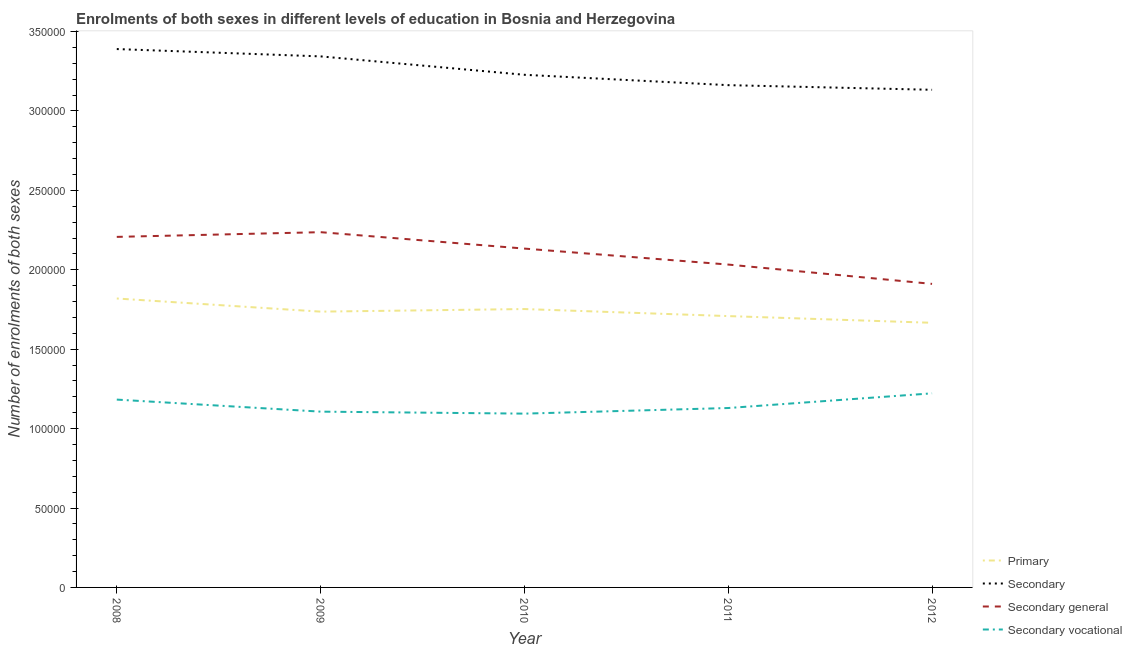How many different coloured lines are there?
Ensure brevity in your answer.  4. Does the line corresponding to number of enrolments in primary education intersect with the line corresponding to number of enrolments in secondary education?
Provide a succinct answer. No. Is the number of lines equal to the number of legend labels?
Offer a very short reply. Yes. What is the number of enrolments in primary education in 2009?
Provide a succinct answer. 1.74e+05. Across all years, what is the maximum number of enrolments in secondary general education?
Provide a short and direct response. 2.24e+05. Across all years, what is the minimum number of enrolments in secondary education?
Provide a short and direct response. 3.13e+05. In which year was the number of enrolments in secondary vocational education minimum?
Offer a very short reply. 2010. What is the total number of enrolments in secondary vocational education in the graph?
Provide a succinct answer. 5.74e+05. What is the difference between the number of enrolments in secondary vocational education in 2008 and that in 2010?
Your answer should be compact. 8838. What is the difference between the number of enrolments in secondary vocational education in 2012 and the number of enrolments in secondary education in 2010?
Give a very brief answer. -2.01e+05. What is the average number of enrolments in secondary general education per year?
Make the answer very short. 2.10e+05. In the year 2012, what is the difference between the number of enrolments in secondary vocational education and number of enrolments in primary education?
Provide a short and direct response. -4.44e+04. What is the ratio of the number of enrolments in secondary general education in 2008 to that in 2010?
Ensure brevity in your answer.  1.03. Is the difference between the number of enrolments in secondary vocational education in 2008 and 2009 greater than the difference between the number of enrolments in secondary education in 2008 and 2009?
Offer a terse response. Yes. What is the difference between the highest and the second highest number of enrolments in secondary education?
Your response must be concise. 4616. What is the difference between the highest and the lowest number of enrolments in secondary vocational education?
Give a very brief answer. 1.28e+04. In how many years, is the number of enrolments in secondary education greater than the average number of enrolments in secondary education taken over all years?
Your response must be concise. 2. Is the sum of the number of enrolments in secondary education in 2008 and 2012 greater than the maximum number of enrolments in secondary vocational education across all years?
Ensure brevity in your answer.  Yes. Is it the case that in every year, the sum of the number of enrolments in primary education and number of enrolments in secondary education is greater than the number of enrolments in secondary general education?
Your answer should be compact. Yes. Does the number of enrolments in primary education monotonically increase over the years?
Keep it short and to the point. No. Is the number of enrolments in secondary vocational education strictly less than the number of enrolments in secondary general education over the years?
Keep it short and to the point. Yes. What is the difference between two consecutive major ticks on the Y-axis?
Keep it short and to the point. 5.00e+04. Are the values on the major ticks of Y-axis written in scientific E-notation?
Make the answer very short. No. Does the graph contain any zero values?
Give a very brief answer. No. How many legend labels are there?
Give a very brief answer. 4. What is the title of the graph?
Keep it short and to the point. Enrolments of both sexes in different levels of education in Bosnia and Herzegovina. Does "France" appear as one of the legend labels in the graph?
Offer a very short reply. No. What is the label or title of the X-axis?
Give a very brief answer. Year. What is the label or title of the Y-axis?
Keep it short and to the point. Number of enrolments of both sexes. What is the Number of enrolments of both sexes of Primary in 2008?
Provide a succinct answer. 1.82e+05. What is the Number of enrolments of both sexes of Secondary in 2008?
Provide a short and direct response. 3.39e+05. What is the Number of enrolments of both sexes in Secondary general in 2008?
Provide a succinct answer. 2.21e+05. What is the Number of enrolments of both sexes of Secondary vocational in 2008?
Keep it short and to the point. 1.18e+05. What is the Number of enrolments of both sexes in Primary in 2009?
Your answer should be very brief. 1.74e+05. What is the Number of enrolments of both sexes of Secondary in 2009?
Your answer should be very brief. 3.34e+05. What is the Number of enrolments of both sexes of Secondary general in 2009?
Offer a terse response. 2.24e+05. What is the Number of enrolments of both sexes of Secondary vocational in 2009?
Keep it short and to the point. 1.11e+05. What is the Number of enrolments of both sexes in Primary in 2010?
Provide a succinct answer. 1.75e+05. What is the Number of enrolments of both sexes of Secondary in 2010?
Offer a very short reply. 3.23e+05. What is the Number of enrolments of both sexes in Secondary general in 2010?
Your response must be concise. 2.13e+05. What is the Number of enrolments of both sexes in Secondary vocational in 2010?
Provide a short and direct response. 1.09e+05. What is the Number of enrolments of both sexes of Primary in 2011?
Give a very brief answer. 1.71e+05. What is the Number of enrolments of both sexes in Secondary in 2011?
Keep it short and to the point. 3.16e+05. What is the Number of enrolments of both sexes in Secondary general in 2011?
Make the answer very short. 2.03e+05. What is the Number of enrolments of both sexes of Secondary vocational in 2011?
Your answer should be compact. 1.13e+05. What is the Number of enrolments of both sexes of Primary in 2012?
Your answer should be compact. 1.67e+05. What is the Number of enrolments of both sexes in Secondary in 2012?
Keep it short and to the point. 3.13e+05. What is the Number of enrolments of both sexes of Secondary general in 2012?
Your answer should be compact. 1.91e+05. What is the Number of enrolments of both sexes of Secondary vocational in 2012?
Provide a short and direct response. 1.22e+05. Across all years, what is the maximum Number of enrolments of both sexes in Primary?
Offer a terse response. 1.82e+05. Across all years, what is the maximum Number of enrolments of both sexes in Secondary?
Your answer should be very brief. 3.39e+05. Across all years, what is the maximum Number of enrolments of both sexes of Secondary general?
Your response must be concise. 2.24e+05. Across all years, what is the maximum Number of enrolments of both sexes in Secondary vocational?
Offer a terse response. 1.22e+05. Across all years, what is the minimum Number of enrolments of both sexes in Primary?
Provide a short and direct response. 1.67e+05. Across all years, what is the minimum Number of enrolments of both sexes of Secondary?
Provide a succinct answer. 3.13e+05. Across all years, what is the minimum Number of enrolments of both sexes of Secondary general?
Make the answer very short. 1.91e+05. Across all years, what is the minimum Number of enrolments of both sexes of Secondary vocational?
Provide a succinct answer. 1.09e+05. What is the total Number of enrolments of both sexes of Primary in the graph?
Your answer should be very brief. 8.68e+05. What is the total Number of enrolments of both sexes of Secondary in the graph?
Make the answer very short. 1.63e+06. What is the total Number of enrolments of both sexes in Secondary general in the graph?
Your answer should be compact. 1.05e+06. What is the total Number of enrolments of both sexes of Secondary vocational in the graph?
Ensure brevity in your answer.  5.74e+05. What is the difference between the Number of enrolments of both sexes in Primary in 2008 and that in 2009?
Make the answer very short. 8270. What is the difference between the Number of enrolments of both sexes of Secondary in 2008 and that in 2009?
Keep it short and to the point. 4616. What is the difference between the Number of enrolments of both sexes of Secondary general in 2008 and that in 2009?
Keep it short and to the point. -2965. What is the difference between the Number of enrolments of both sexes in Secondary vocational in 2008 and that in 2009?
Your response must be concise. 7581. What is the difference between the Number of enrolments of both sexes of Primary in 2008 and that in 2010?
Ensure brevity in your answer.  6646. What is the difference between the Number of enrolments of both sexes in Secondary in 2008 and that in 2010?
Provide a short and direct response. 1.62e+04. What is the difference between the Number of enrolments of both sexes of Secondary general in 2008 and that in 2010?
Ensure brevity in your answer.  7367. What is the difference between the Number of enrolments of both sexes of Secondary vocational in 2008 and that in 2010?
Provide a succinct answer. 8838. What is the difference between the Number of enrolments of both sexes in Primary in 2008 and that in 2011?
Give a very brief answer. 1.11e+04. What is the difference between the Number of enrolments of both sexes in Secondary in 2008 and that in 2011?
Offer a very short reply. 2.27e+04. What is the difference between the Number of enrolments of both sexes of Secondary general in 2008 and that in 2011?
Provide a short and direct response. 1.74e+04. What is the difference between the Number of enrolments of both sexes of Secondary vocational in 2008 and that in 2011?
Provide a short and direct response. 5300. What is the difference between the Number of enrolments of both sexes in Primary in 2008 and that in 2012?
Your answer should be very brief. 1.53e+04. What is the difference between the Number of enrolments of both sexes in Secondary in 2008 and that in 2012?
Offer a very short reply. 2.56e+04. What is the difference between the Number of enrolments of both sexes of Secondary general in 2008 and that in 2012?
Offer a very short reply. 2.96e+04. What is the difference between the Number of enrolments of both sexes in Secondary vocational in 2008 and that in 2012?
Provide a short and direct response. -3941. What is the difference between the Number of enrolments of both sexes in Primary in 2009 and that in 2010?
Make the answer very short. -1624. What is the difference between the Number of enrolments of both sexes in Secondary in 2009 and that in 2010?
Provide a succinct answer. 1.16e+04. What is the difference between the Number of enrolments of both sexes in Secondary general in 2009 and that in 2010?
Your answer should be very brief. 1.03e+04. What is the difference between the Number of enrolments of both sexes in Secondary vocational in 2009 and that in 2010?
Your response must be concise. 1257. What is the difference between the Number of enrolments of both sexes of Primary in 2009 and that in 2011?
Make the answer very short. 2805. What is the difference between the Number of enrolments of both sexes of Secondary in 2009 and that in 2011?
Ensure brevity in your answer.  1.81e+04. What is the difference between the Number of enrolments of both sexes in Secondary general in 2009 and that in 2011?
Offer a very short reply. 2.04e+04. What is the difference between the Number of enrolments of both sexes in Secondary vocational in 2009 and that in 2011?
Offer a very short reply. -2281. What is the difference between the Number of enrolments of both sexes of Primary in 2009 and that in 2012?
Your response must be concise. 7027. What is the difference between the Number of enrolments of both sexes of Secondary in 2009 and that in 2012?
Offer a terse response. 2.10e+04. What is the difference between the Number of enrolments of both sexes of Secondary general in 2009 and that in 2012?
Keep it short and to the point. 3.26e+04. What is the difference between the Number of enrolments of both sexes in Secondary vocational in 2009 and that in 2012?
Offer a terse response. -1.15e+04. What is the difference between the Number of enrolments of both sexes of Primary in 2010 and that in 2011?
Ensure brevity in your answer.  4429. What is the difference between the Number of enrolments of both sexes of Secondary in 2010 and that in 2011?
Give a very brief answer. 6525. What is the difference between the Number of enrolments of both sexes in Secondary general in 2010 and that in 2011?
Provide a short and direct response. 1.01e+04. What is the difference between the Number of enrolments of both sexes of Secondary vocational in 2010 and that in 2011?
Keep it short and to the point. -3538. What is the difference between the Number of enrolments of both sexes in Primary in 2010 and that in 2012?
Make the answer very short. 8651. What is the difference between the Number of enrolments of both sexes in Secondary in 2010 and that in 2012?
Your answer should be very brief. 9445. What is the difference between the Number of enrolments of both sexes in Secondary general in 2010 and that in 2012?
Offer a very short reply. 2.22e+04. What is the difference between the Number of enrolments of both sexes of Secondary vocational in 2010 and that in 2012?
Your response must be concise. -1.28e+04. What is the difference between the Number of enrolments of both sexes in Primary in 2011 and that in 2012?
Offer a terse response. 4222. What is the difference between the Number of enrolments of both sexes of Secondary in 2011 and that in 2012?
Keep it short and to the point. 2920. What is the difference between the Number of enrolments of both sexes of Secondary general in 2011 and that in 2012?
Keep it short and to the point. 1.22e+04. What is the difference between the Number of enrolments of both sexes in Secondary vocational in 2011 and that in 2012?
Make the answer very short. -9241. What is the difference between the Number of enrolments of both sexes in Primary in 2008 and the Number of enrolments of both sexes in Secondary in 2009?
Your answer should be compact. -1.52e+05. What is the difference between the Number of enrolments of both sexes of Primary in 2008 and the Number of enrolments of both sexes of Secondary general in 2009?
Your response must be concise. -4.18e+04. What is the difference between the Number of enrolments of both sexes in Primary in 2008 and the Number of enrolments of both sexes in Secondary vocational in 2009?
Offer a terse response. 7.12e+04. What is the difference between the Number of enrolments of both sexes in Secondary in 2008 and the Number of enrolments of both sexes in Secondary general in 2009?
Make the answer very short. 1.15e+05. What is the difference between the Number of enrolments of both sexes in Secondary in 2008 and the Number of enrolments of both sexes in Secondary vocational in 2009?
Make the answer very short. 2.28e+05. What is the difference between the Number of enrolments of both sexes of Secondary general in 2008 and the Number of enrolments of both sexes of Secondary vocational in 2009?
Ensure brevity in your answer.  1.10e+05. What is the difference between the Number of enrolments of both sexes in Primary in 2008 and the Number of enrolments of both sexes in Secondary in 2010?
Your response must be concise. -1.41e+05. What is the difference between the Number of enrolments of both sexes of Primary in 2008 and the Number of enrolments of both sexes of Secondary general in 2010?
Your answer should be compact. -3.14e+04. What is the difference between the Number of enrolments of both sexes of Primary in 2008 and the Number of enrolments of both sexes of Secondary vocational in 2010?
Give a very brief answer. 7.25e+04. What is the difference between the Number of enrolments of both sexes in Secondary in 2008 and the Number of enrolments of both sexes in Secondary general in 2010?
Offer a very short reply. 1.26e+05. What is the difference between the Number of enrolments of both sexes in Secondary in 2008 and the Number of enrolments of both sexes in Secondary vocational in 2010?
Offer a very short reply. 2.30e+05. What is the difference between the Number of enrolments of both sexes of Secondary general in 2008 and the Number of enrolments of both sexes of Secondary vocational in 2010?
Ensure brevity in your answer.  1.11e+05. What is the difference between the Number of enrolments of both sexes of Primary in 2008 and the Number of enrolments of both sexes of Secondary in 2011?
Your answer should be very brief. -1.34e+05. What is the difference between the Number of enrolments of both sexes of Primary in 2008 and the Number of enrolments of both sexes of Secondary general in 2011?
Offer a very short reply. -2.14e+04. What is the difference between the Number of enrolments of both sexes of Primary in 2008 and the Number of enrolments of both sexes of Secondary vocational in 2011?
Give a very brief answer. 6.90e+04. What is the difference between the Number of enrolments of both sexes in Secondary in 2008 and the Number of enrolments of both sexes in Secondary general in 2011?
Your response must be concise. 1.36e+05. What is the difference between the Number of enrolments of both sexes of Secondary in 2008 and the Number of enrolments of both sexes of Secondary vocational in 2011?
Provide a short and direct response. 2.26e+05. What is the difference between the Number of enrolments of both sexes in Secondary general in 2008 and the Number of enrolments of both sexes in Secondary vocational in 2011?
Make the answer very short. 1.08e+05. What is the difference between the Number of enrolments of both sexes of Primary in 2008 and the Number of enrolments of both sexes of Secondary in 2012?
Your answer should be compact. -1.31e+05. What is the difference between the Number of enrolments of both sexes of Primary in 2008 and the Number of enrolments of both sexes of Secondary general in 2012?
Provide a succinct answer. -9201. What is the difference between the Number of enrolments of both sexes of Primary in 2008 and the Number of enrolments of both sexes of Secondary vocational in 2012?
Provide a succinct answer. 5.97e+04. What is the difference between the Number of enrolments of both sexes of Secondary in 2008 and the Number of enrolments of both sexes of Secondary general in 2012?
Offer a terse response. 1.48e+05. What is the difference between the Number of enrolments of both sexes in Secondary in 2008 and the Number of enrolments of both sexes in Secondary vocational in 2012?
Offer a terse response. 2.17e+05. What is the difference between the Number of enrolments of both sexes of Secondary general in 2008 and the Number of enrolments of both sexes of Secondary vocational in 2012?
Make the answer very short. 9.85e+04. What is the difference between the Number of enrolments of both sexes of Primary in 2009 and the Number of enrolments of both sexes of Secondary in 2010?
Your answer should be very brief. -1.49e+05. What is the difference between the Number of enrolments of both sexes in Primary in 2009 and the Number of enrolments of both sexes in Secondary general in 2010?
Your answer should be compact. -3.97e+04. What is the difference between the Number of enrolments of both sexes in Primary in 2009 and the Number of enrolments of both sexes in Secondary vocational in 2010?
Your response must be concise. 6.42e+04. What is the difference between the Number of enrolments of both sexes in Secondary in 2009 and the Number of enrolments of both sexes in Secondary general in 2010?
Your response must be concise. 1.21e+05. What is the difference between the Number of enrolments of both sexes in Secondary in 2009 and the Number of enrolments of both sexes in Secondary vocational in 2010?
Provide a short and direct response. 2.25e+05. What is the difference between the Number of enrolments of both sexes in Secondary general in 2009 and the Number of enrolments of both sexes in Secondary vocational in 2010?
Provide a succinct answer. 1.14e+05. What is the difference between the Number of enrolments of both sexes in Primary in 2009 and the Number of enrolments of both sexes in Secondary in 2011?
Make the answer very short. -1.43e+05. What is the difference between the Number of enrolments of both sexes of Primary in 2009 and the Number of enrolments of both sexes of Secondary general in 2011?
Your response must be concise. -2.96e+04. What is the difference between the Number of enrolments of both sexes in Primary in 2009 and the Number of enrolments of both sexes in Secondary vocational in 2011?
Offer a terse response. 6.07e+04. What is the difference between the Number of enrolments of both sexes of Secondary in 2009 and the Number of enrolments of both sexes of Secondary general in 2011?
Keep it short and to the point. 1.31e+05. What is the difference between the Number of enrolments of both sexes in Secondary in 2009 and the Number of enrolments of both sexes in Secondary vocational in 2011?
Your response must be concise. 2.21e+05. What is the difference between the Number of enrolments of both sexes of Secondary general in 2009 and the Number of enrolments of both sexes of Secondary vocational in 2011?
Keep it short and to the point. 1.11e+05. What is the difference between the Number of enrolments of both sexes in Primary in 2009 and the Number of enrolments of both sexes in Secondary in 2012?
Offer a terse response. -1.40e+05. What is the difference between the Number of enrolments of both sexes of Primary in 2009 and the Number of enrolments of both sexes of Secondary general in 2012?
Make the answer very short. -1.75e+04. What is the difference between the Number of enrolments of both sexes in Primary in 2009 and the Number of enrolments of both sexes in Secondary vocational in 2012?
Offer a terse response. 5.14e+04. What is the difference between the Number of enrolments of both sexes of Secondary in 2009 and the Number of enrolments of both sexes of Secondary general in 2012?
Make the answer very short. 1.43e+05. What is the difference between the Number of enrolments of both sexes in Secondary in 2009 and the Number of enrolments of both sexes in Secondary vocational in 2012?
Your answer should be compact. 2.12e+05. What is the difference between the Number of enrolments of both sexes of Secondary general in 2009 and the Number of enrolments of both sexes of Secondary vocational in 2012?
Offer a very short reply. 1.01e+05. What is the difference between the Number of enrolments of both sexes of Primary in 2010 and the Number of enrolments of both sexes of Secondary in 2011?
Ensure brevity in your answer.  -1.41e+05. What is the difference between the Number of enrolments of both sexes in Primary in 2010 and the Number of enrolments of both sexes in Secondary general in 2011?
Ensure brevity in your answer.  -2.80e+04. What is the difference between the Number of enrolments of both sexes of Primary in 2010 and the Number of enrolments of both sexes of Secondary vocational in 2011?
Keep it short and to the point. 6.23e+04. What is the difference between the Number of enrolments of both sexes of Secondary in 2010 and the Number of enrolments of both sexes of Secondary general in 2011?
Provide a short and direct response. 1.19e+05. What is the difference between the Number of enrolments of both sexes in Secondary in 2010 and the Number of enrolments of both sexes in Secondary vocational in 2011?
Offer a very short reply. 2.10e+05. What is the difference between the Number of enrolments of both sexes in Secondary general in 2010 and the Number of enrolments of both sexes in Secondary vocational in 2011?
Your answer should be very brief. 1.00e+05. What is the difference between the Number of enrolments of both sexes of Primary in 2010 and the Number of enrolments of both sexes of Secondary in 2012?
Make the answer very short. -1.38e+05. What is the difference between the Number of enrolments of both sexes of Primary in 2010 and the Number of enrolments of both sexes of Secondary general in 2012?
Your response must be concise. -1.58e+04. What is the difference between the Number of enrolments of both sexes of Primary in 2010 and the Number of enrolments of both sexes of Secondary vocational in 2012?
Your answer should be very brief. 5.31e+04. What is the difference between the Number of enrolments of both sexes in Secondary in 2010 and the Number of enrolments of both sexes in Secondary general in 2012?
Your answer should be very brief. 1.32e+05. What is the difference between the Number of enrolments of both sexes in Secondary in 2010 and the Number of enrolments of both sexes in Secondary vocational in 2012?
Offer a very short reply. 2.01e+05. What is the difference between the Number of enrolments of both sexes of Secondary general in 2010 and the Number of enrolments of both sexes of Secondary vocational in 2012?
Your answer should be very brief. 9.11e+04. What is the difference between the Number of enrolments of both sexes of Primary in 2011 and the Number of enrolments of both sexes of Secondary in 2012?
Offer a terse response. -1.42e+05. What is the difference between the Number of enrolments of both sexes in Primary in 2011 and the Number of enrolments of both sexes in Secondary general in 2012?
Keep it short and to the point. -2.03e+04. What is the difference between the Number of enrolments of both sexes in Primary in 2011 and the Number of enrolments of both sexes in Secondary vocational in 2012?
Your answer should be very brief. 4.86e+04. What is the difference between the Number of enrolments of both sexes in Secondary in 2011 and the Number of enrolments of both sexes in Secondary general in 2012?
Offer a very short reply. 1.25e+05. What is the difference between the Number of enrolments of both sexes in Secondary in 2011 and the Number of enrolments of both sexes in Secondary vocational in 2012?
Your answer should be very brief. 1.94e+05. What is the difference between the Number of enrolments of both sexes in Secondary general in 2011 and the Number of enrolments of both sexes in Secondary vocational in 2012?
Your answer should be compact. 8.11e+04. What is the average Number of enrolments of both sexes in Primary per year?
Your answer should be very brief. 1.74e+05. What is the average Number of enrolments of both sexes in Secondary per year?
Your answer should be very brief. 3.25e+05. What is the average Number of enrolments of both sexes of Secondary general per year?
Make the answer very short. 2.10e+05. What is the average Number of enrolments of both sexes in Secondary vocational per year?
Provide a succinct answer. 1.15e+05. In the year 2008, what is the difference between the Number of enrolments of both sexes of Primary and Number of enrolments of both sexes of Secondary?
Keep it short and to the point. -1.57e+05. In the year 2008, what is the difference between the Number of enrolments of both sexes in Primary and Number of enrolments of both sexes in Secondary general?
Your answer should be compact. -3.88e+04. In the year 2008, what is the difference between the Number of enrolments of both sexes of Primary and Number of enrolments of both sexes of Secondary vocational?
Ensure brevity in your answer.  6.37e+04. In the year 2008, what is the difference between the Number of enrolments of both sexes in Secondary and Number of enrolments of both sexes in Secondary general?
Your response must be concise. 1.18e+05. In the year 2008, what is the difference between the Number of enrolments of both sexes of Secondary and Number of enrolments of both sexes of Secondary vocational?
Offer a very short reply. 2.21e+05. In the year 2008, what is the difference between the Number of enrolments of both sexes in Secondary general and Number of enrolments of both sexes in Secondary vocational?
Provide a short and direct response. 1.02e+05. In the year 2009, what is the difference between the Number of enrolments of both sexes in Primary and Number of enrolments of both sexes in Secondary?
Offer a terse response. -1.61e+05. In the year 2009, what is the difference between the Number of enrolments of both sexes in Primary and Number of enrolments of both sexes in Secondary general?
Offer a very short reply. -5.00e+04. In the year 2009, what is the difference between the Number of enrolments of both sexes of Primary and Number of enrolments of both sexes of Secondary vocational?
Offer a very short reply. 6.30e+04. In the year 2009, what is the difference between the Number of enrolments of both sexes of Secondary and Number of enrolments of both sexes of Secondary general?
Keep it short and to the point. 1.11e+05. In the year 2009, what is the difference between the Number of enrolments of both sexes in Secondary and Number of enrolments of both sexes in Secondary vocational?
Provide a short and direct response. 2.24e+05. In the year 2009, what is the difference between the Number of enrolments of both sexes in Secondary general and Number of enrolments of both sexes in Secondary vocational?
Offer a terse response. 1.13e+05. In the year 2010, what is the difference between the Number of enrolments of both sexes in Primary and Number of enrolments of both sexes in Secondary?
Give a very brief answer. -1.47e+05. In the year 2010, what is the difference between the Number of enrolments of both sexes in Primary and Number of enrolments of both sexes in Secondary general?
Offer a very short reply. -3.81e+04. In the year 2010, what is the difference between the Number of enrolments of both sexes in Primary and Number of enrolments of both sexes in Secondary vocational?
Offer a terse response. 6.58e+04. In the year 2010, what is the difference between the Number of enrolments of both sexes in Secondary and Number of enrolments of both sexes in Secondary general?
Your answer should be compact. 1.09e+05. In the year 2010, what is the difference between the Number of enrolments of both sexes in Secondary and Number of enrolments of both sexes in Secondary vocational?
Offer a very short reply. 2.13e+05. In the year 2010, what is the difference between the Number of enrolments of both sexes of Secondary general and Number of enrolments of both sexes of Secondary vocational?
Offer a very short reply. 1.04e+05. In the year 2011, what is the difference between the Number of enrolments of both sexes of Primary and Number of enrolments of both sexes of Secondary?
Keep it short and to the point. -1.45e+05. In the year 2011, what is the difference between the Number of enrolments of both sexes in Primary and Number of enrolments of both sexes in Secondary general?
Provide a succinct answer. -3.24e+04. In the year 2011, what is the difference between the Number of enrolments of both sexes of Primary and Number of enrolments of both sexes of Secondary vocational?
Offer a terse response. 5.79e+04. In the year 2011, what is the difference between the Number of enrolments of both sexes of Secondary and Number of enrolments of both sexes of Secondary general?
Keep it short and to the point. 1.13e+05. In the year 2011, what is the difference between the Number of enrolments of both sexes of Secondary and Number of enrolments of both sexes of Secondary vocational?
Your response must be concise. 2.03e+05. In the year 2011, what is the difference between the Number of enrolments of both sexes of Secondary general and Number of enrolments of both sexes of Secondary vocational?
Keep it short and to the point. 9.03e+04. In the year 2012, what is the difference between the Number of enrolments of both sexes in Primary and Number of enrolments of both sexes in Secondary?
Keep it short and to the point. -1.47e+05. In the year 2012, what is the difference between the Number of enrolments of both sexes of Primary and Number of enrolments of both sexes of Secondary general?
Offer a very short reply. -2.45e+04. In the year 2012, what is the difference between the Number of enrolments of both sexes in Primary and Number of enrolments of both sexes in Secondary vocational?
Keep it short and to the point. 4.44e+04. In the year 2012, what is the difference between the Number of enrolments of both sexes in Secondary and Number of enrolments of both sexes in Secondary general?
Provide a succinct answer. 1.22e+05. In the year 2012, what is the difference between the Number of enrolments of both sexes in Secondary and Number of enrolments of both sexes in Secondary vocational?
Make the answer very short. 1.91e+05. In the year 2012, what is the difference between the Number of enrolments of both sexes in Secondary general and Number of enrolments of both sexes in Secondary vocational?
Offer a very short reply. 6.89e+04. What is the ratio of the Number of enrolments of both sexes of Primary in 2008 to that in 2009?
Your response must be concise. 1.05. What is the ratio of the Number of enrolments of both sexes of Secondary in 2008 to that in 2009?
Your response must be concise. 1.01. What is the ratio of the Number of enrolments of both sexes in Secondary general in 2008 to that in 2009?
Keep it short and to the point. 0.99. What is the ratio of the Number of enrolments of both sexes of Secondary vocational in 2008 to that in 2009?
Offer a very short reply. 1.07. What is the ratio of the Number of enrolments of both sexes in Primary in 2008 to that in 2010?
Offer a terse response. 1.04. What is the ratio of the Number of enrolments of both sexes of Secondary in 2008 to that in 2010?
Your answer should be compact. 1.05. What is the ratio of the Number of enrolments of both sexes in Secondary general in 2008 to that in 2010?
Your response must be concise. 1.03. What is the ratio of the Number of enrolments of both sexes in Secondary vocational in 2008 to that in 2010?
Give a very brief answer. 1.08. What is the ratio of the Number of enrolments of both sexes in Primary in 2008 to that in 2011?
Your answer should be very brief. 1.06. What is the ratio of the Number of enrolments of both sexes in Secondary in 2008 to that in 2011?
Your response must be concise. 1.07. What is the ratio of the Number of enrolments of both sexes of Secondary general in 2008 to that in 2011?
Offer a terse response. 1.09. What is the ratio of the Number of enrolments of both sexes of Secondary vocational in 2008 to that in 2011?
Your answer should be very brief. 1.05. What is the ratio of the Number of enrolments of both sexes in Primary in 2008 to that in 2012?
Keep it short and to the point. 1.09. What is the ratio of the Number of enrolments of both sexes in Secondary in 2008 to that in 2012?
Give a very brief answer. 1.08. What is the ratio of the Number of enrolments of both sexes of Secondary general in 2008 to that in 2012?
Provide a short and direct response. 1.15. What is the ratio of the Number of enrolments of both sexes of Secondary vocational in 2008 to that in 2012?
Your answer should be very brief. 0.97. What is the ratio of the Number of enrolments of both sexes of Primary in 2009 to that in 2010?
Keep it short and to the point. 0.99. What is the ratio of the Number of enrolments of both sexes in Secondary in 2009 to that in 2010?
Your answer should be very brief. 1.04. What is the ratio of the Number of enrolments of both sexes of Secondary general in 2009 to that in 2010?
Your answer should be very brief. 1.05. What is the ratio of the Number of enrolments of both sexes in Secondary vocational in 2009 to that in 2010?
Your response must be concise. 1.01. What is the ratio of the Number of enrolments of both sexes of Primary in 2009 to that in 2011?
Offer a very short reply. 1.02. What is the ratio of the Number of enrolments of both sexes of Secondary in 2009 to that in 2011?
Offer a terse response. 1.06. What is the ratio of the Number of enrolments of both sexes in Secondary general in 2009 to that in 2011?
Keep it short and to the point. 1.1. What is the ratio of the Number of enrolments of both sexes in Secondary vocational in 2009 to that in 2011?
Ensure brevity in your answer.  0.98. What is the ratio of the Number of enrolments of both sexes in Primary in 2009 to that in 2012?
Provide a short and direct response. 1.04. What is the ratio of the Number of enrolments of both sexes of Secondary in 2009 to that in 2012?
Provide a short and direct response. 1.07. What is the ratio of the Number of enrolments of both sexes of Secondary general in 2009 to that in 2012?
Your response must be concise. 1.17. What is the ratio of the Number of enrolments of both sexes in Secondary vocational in 2009 to that in 2012?
Make the answer very short. 0.91. What is the ratio of the Number of enrolments of both sexes in Primary in 2010 to that in 2011?
Your response must be concise. 1.03. What is the ratio of the Number of enrolments of both sexes in Secondary in 2010 to that in 2011?
Your answer should be very brief. 1.02. What is the ratio of the Number of enrolments of both sexes of Secondary general in 2010 to that in 2011?
Provide a short and direct response. 1.05. What is the ratio of the Number of enrolments of both sexes in Secondary vocational in 2010 to that in 2011?
Provide a short and direct response. 0.97. What is the ratio of the Number of enrolments of both sexes of Primary in 2010 to that in 2012?
Your answer should be very brief. 1.05. What is the ratio of the Number of enrolments of both sexes of Secondary in 2010 to that in 2012?
Offer a terse response. 1.03. What is the ratio of the Number of enrolments of both sexes in Secondary general in 2010 to that in 2012?
Make the answer very short. 1.12. What is the ratio of the Number of enrolments of both sexes in Secondary vocational in 2010 to that in 2012?
Your answer should be compact. 0.9. What is the ratio of the Number of enrolments of both sexes of Primary in 2011 to that in 2012?
Offer a very short reply. 1.03. What is the ratio of the Number of enrolments of both sexes in Secondary in 2011 to that in 2012?
Your response must be concise. 1.01. What is the ratio of the Number of enrolments of both sexes of Secondary general in 2011 to that in 2012?
Keep it short and to the point. 1.06. What is the ratio of the Number of enrolments of both sexes in Secondary vocational in 2011 to that in 2012?
Keep it short and to the point. 0.92. What is the difference between the highest and the second highest Number of enrolments of both sexes of Primary?
Keep it short and to the point. 6646. What is the difference between the highest and the second highest Number of enrolments of both sexes of Secondary?
Offer a terse response. 4616. What is the difference between the highest and the second highest Number of enrolments of both sexes in Secondary general?
Provide a short and direct response. 2965. What is the difference between the highest and the second highest Number of enrolments of both sexes in Secondary vocational?
Make the answer very short. 3941. What is the difference between the highest and the lowest Number of enrolments of both sexes of Primary?
Your response must be concise. 1.53e+04. What is the difference between the highest and the lowest Number of enrolments of both sexes of Secondary?
Ensure brevity in your answer.  2.56e+04. What is the difference between the highest and the lowest Number of enrolments of both sexes in Secondary general?
Provide a succinct answer. 3.26e+04. What is the difference between the highest and the lowest Number of enrolments of both sexes of Secondary vocational?
Make the answer very short. 1.28e+04. 